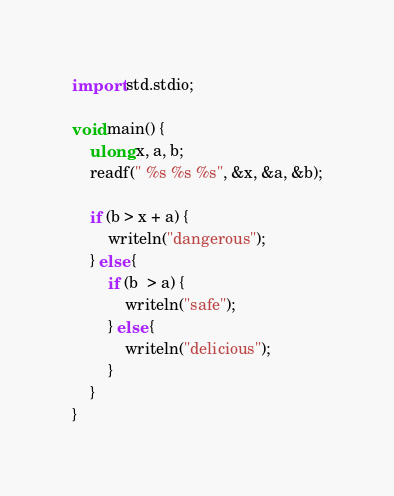<code> <loc_0><loc_0><loc_500><loc_500><_D_>import std.stdio;

void main() {
    ulong x, a, b;
    readf(" %s %s %s", &x, &a, &b);

    if (b > x + a) {
        writeln("dangerous");
    } else {
        if (b  > a) {
            writeln("safe");
        } else {
            writeln("delicious");
        }
    }
}</code> 